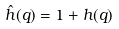<formula> <loc_0><loc_0><loc_500><loc_500>\hat { h } ( q ) = 1 + h ( q )</formula> 